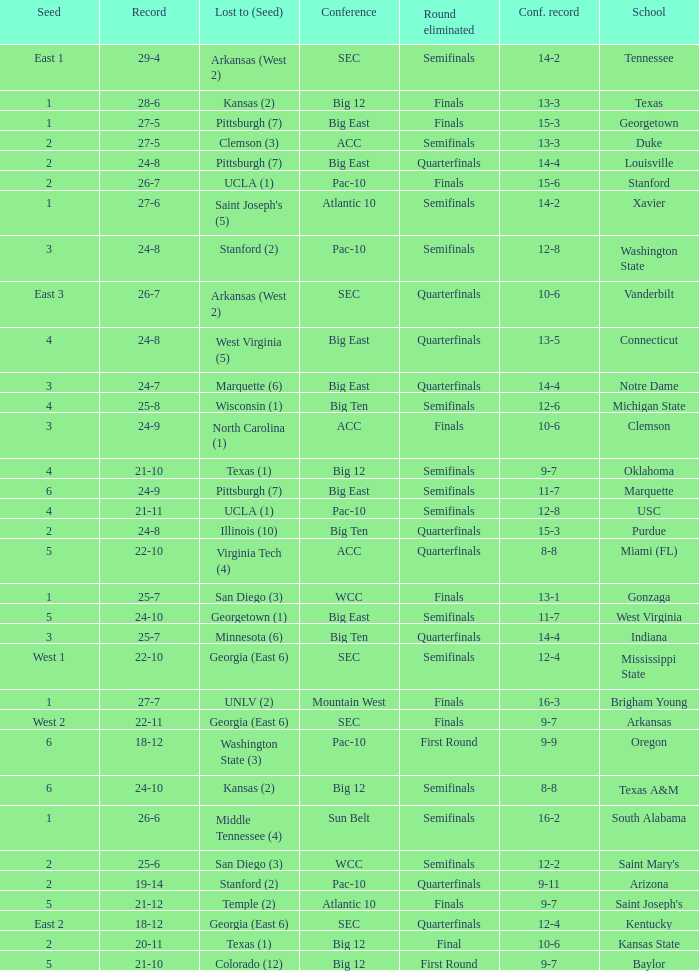Name the conference record where seed is 3 and record is 24-9 10-6. 